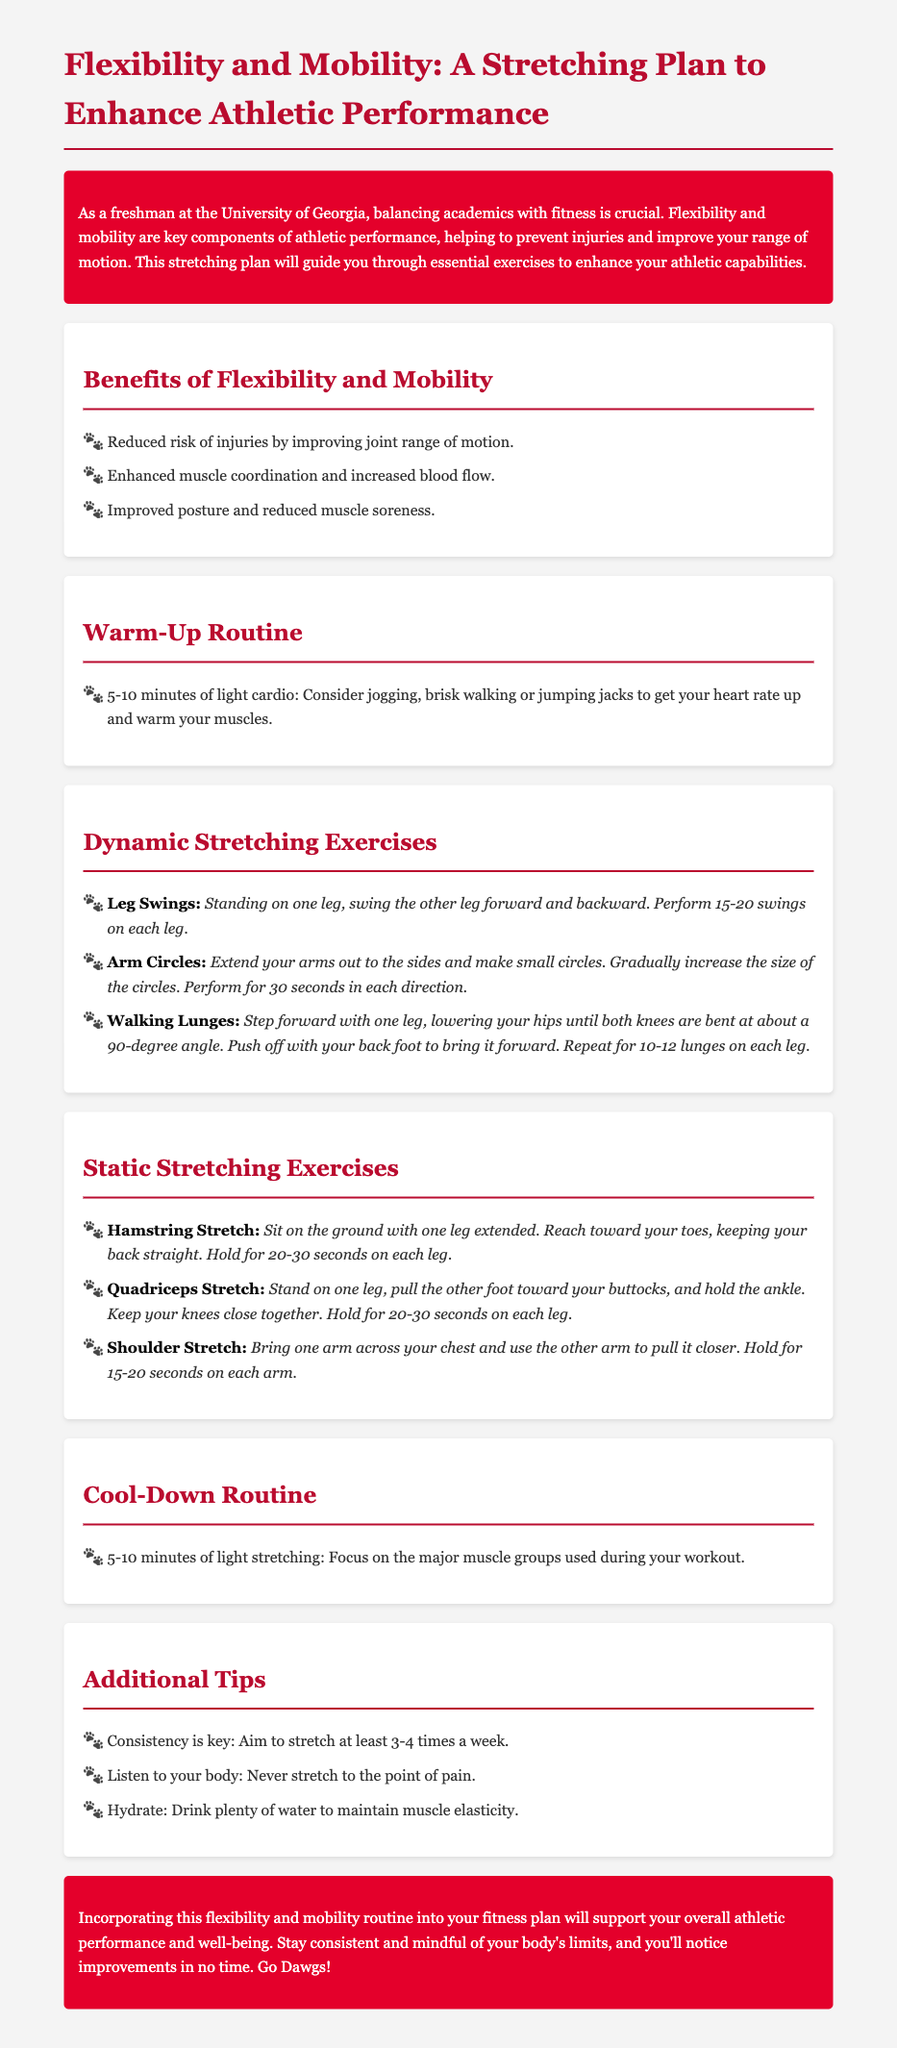What is the title of the document? The title of the document is provided in the `<title>` tag, which is about flexibility and mobility for athletic performance.
Answer: Flexibility and Mobility: A Stretching Plan to Enhance Athletic Performance What are the benefits of flexibility and mobility? The document lists specific benefits in a section dedicated to it, including reduced injury risk and improved posture.
Answer: Reduced risk of injuries by improving joint range of motion, enhanced muscle coordination and increased blood flow, improved posture and reduced muscle soreness How long should the warm-up routine last? The warm-up routine duration is specified at the beginning of the warm-up section in the document.
Answer: 5-10 minutes What is one dynamic stretching exercise mentioned? The document includes several dynamic stretches; one example is highlighted within the list.
Answer: Leg Swings How long should you hold the hamstring stretch? The duration for holding the hamstring stretch is specified in the static stretching exercises section.
Answer: 20-30 seconds How frequently should you stretch according to the additional tips? The recommendations for stretching frequency are provided in the additional tips section of the document.
Answer: 3-4 times a week What is suggested for hydration in the additional tips? The additional tips section mentions hydration to maintain muscle elasticity, indicating the importance of water.
Answer: Drink plenty of water What should you focus on during the cool-down routine? The document specifies what to concentrate on during the cool-down in the respective section.
Answer: Major muscle groups used during your workout 